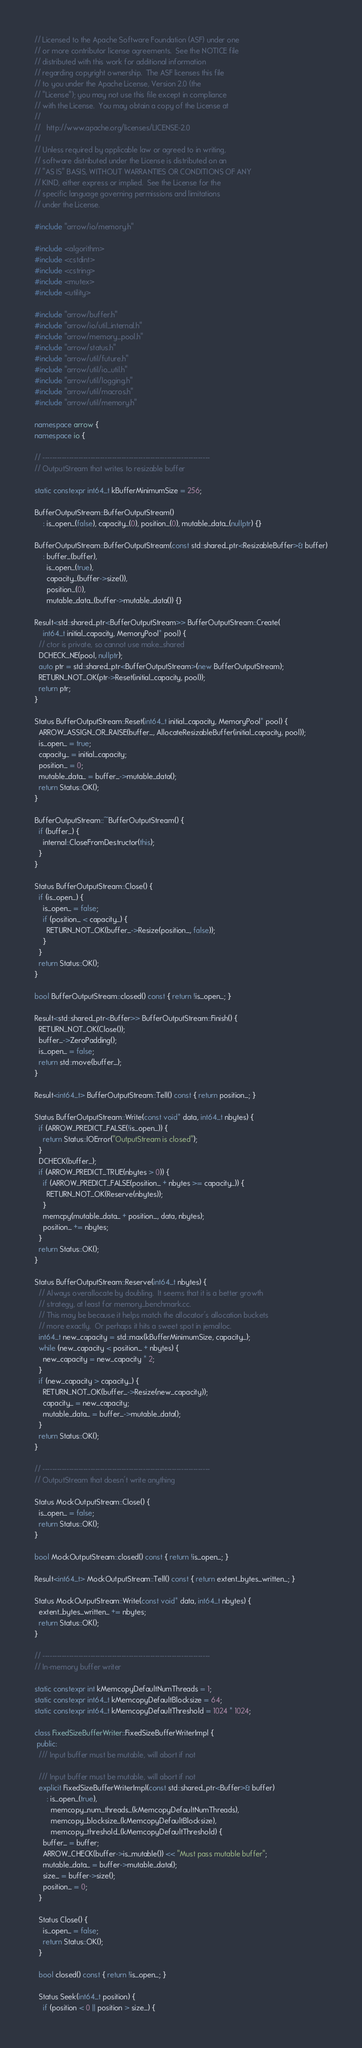Convert code to text. <code><loc_0><loc_0><loc_500><loc_500><_C++_>// Licensed to the Apache Software Foundation (ASF) under one
// or more contributor license agreements.  See the NOTICE file
// distributed with this work for additional information
// regarding copyright ownership.  The ASF licenses this file
// to you under the Apache License, Version 2.0 (the
// "License"); you may not use this file except in compliance
// with the License.  You may obtain a copy of the License at
//
//   http://www.apache.org/licenses/LICENSE-2.0
//
// Unless required by applicable law or agreed to in writing,
// software distributed under the License is distributed on an
// "AS IS" BASIS, WITHOUT WARRANTIES OR CONDITIONS OF ANY
// KIND, either express or implied.  See the License for the
// specific language governing permissions and limitations
// under the License.

#include "arrow/io/memory.h"

#include <algorithm>
#include <cstdint>
#include <cstring>
#include <mutex>
#include <utility>

#include "arrow/buffer.h"
#include "arrow/io/util_internal.h"
#include "arrow/memory_pool.h"
#include "arrow/status.h"
#include "arrow/util/future.h"
#include "arrow/util/io_util.h"
#include "arrow/util/logging.h"
#include "arrow/util/macros.h"
#include "arrow/util/memory.h"

namespace arrow {
namespace io {

// ----------------------------------------------------------------------
// OutputStream that writes to resizable buffer

static constexpr int64_t kBufferMinimumSize = 256;

BufferOutputStream::BufferOutputStream()
    : is_open_(false), capacity_(0), position_(0), mutable_data_(nullptr) {}

BufferOutputStream::BufferOutputStream(const std::shared_ptr<ResizableBuffer>& buffer)
    : buffer_(buffer),
      is_open_(true),
      capacity_(buffer->size()),
      position_(0),
      mutable_data_(buffer->mutable_data()) {}

Result<std::shared_ptr<BufferOutputStream>> BufferOutputStream::Create(
    int64_t initial_capacity, MemoryPool* pool) {
  // ctor is private, so cannot use make_shared
  DCHECK_NE(pool, nullptr);
  auto ptr = std::shared_ptr<BufferOutputStream>(new BufferOutputStream);
  RETURN_NOT_OK(ptr->Reset(initial_capacity, pool));
  return ptr;
}

Status BufferOutputStream::Reset(int64_t initial_capacity, MemoryPool* pool) {
  ARROW_ASSIGN_OR_RAISE(buffer_, AllocateResizableBuffer(initial_capacity, pool));
  is_open_ = true;
  capacity_ = initial_capacity;
  position_ = 0;
  mutable_data_ = buffer_->mutable_data();
  return Status::OK();
}

BufferOutputStream::~BufferOutputStream() {
  if (buffer_) {
    internal::CloseFromDestructor(this);
  }
}

Status BufferOutputStream::Close() {
  if (is_open_) {
    is_open_ = false;
    if (position_ < capacity_) {
      RETURN_NOT_OK(buffer_->Resize(position_, false));
    }
  }
  return Status::OK();
}

bool BufferOutputStream::closed() const { return !is_open_; }

Result<std::shared_ptr<Buffer>> BufferOutputStream::Finish() {
  RETURN_NOT_OK(Close());
  buffer_->ZeroPadding();
  is_open_ = false;
  return std::move(buffer_);
}

Result<int64_t> BufferOutputStream::Tell() const { return position_; }

Status BufferOutputStream::Write(const void* data, int64_t nbytes) {
  if (ARROW_PREDICT_FALSE(!is_open_)) {
    return Status::IOError("OutputStream is closed");
  }
  DCHECK(buffer_);
  if (ARROW_PREDICT_TRUE(nbytes > 0)) {
    if (ARROW_PREDICT_FALSE(position_ + nbytes >= capacity_)) {
      RETURN_NOT_OK(Reserve(nbytes));
    }
    memcpy(mutable_data_ + position_, data, nbytes);
    position_ += nbytes;
  }
  return Status::OK();
}

Status BufferOutputStream::Reserve(int64_t nbytes) {
  // Always overallocate by doubling.  It seems that it is a better growth
  // strategy, at least for memory_benchmark.cc.
  // This may be because it helps match the allocator's allocation buckets
  // more exactly.  Or perhaps it hits a sweet spot in jemalloc.
  int64_t new_capacity = std::max(kBufferMinimumSize, capacity_);
  while (new_capacity < position_ + nbytes) {
    new_capacity = new_capacity * 2;
  }
  if (new_capacity > capacity_) {
    RETURN_NOT_OK(buffer_->Resize(new_capacity));
    capacity_ = new_capacity;
    mutable_data_ = buffer_->mutable_data();
  }
  return Status::OK();
}

// ----------------------------------------------------------------------
// OutputStream that doesn't write anything

Status MockOutputStream::Close() {
  is_open_ = false;
  return Status::OK();
}

bool MockOutputStream::closed() const { return !is_open_; }

Result<int64_t> MockOutputStream::Tell() const { return extent_bytes_written_; }

Status MockOutputStream::Write(const void* data, int64_t nbytes) {
  extent_bytes_written_ += nbytes;
  return Status::OK();
}

// ----------------------------------------------------------------------
// In-memory buffer writer

static constexpr int kMemcopyDefaultNumThreads = 1;
static constexpr int64_t kMemcopyDefaultBlocksize = 64;
static constexpr int64_t kMemcopyDefaultThreshold = 1024 * 1024;

class FixedSizeBufferWriter::FixedSizeBufferWriterImpl {
 public:
  /// Input buffer must be mutable, will abort if not

  /// Input buffer must be mutable, will abort if not
  explicit FixedSizeBufferWriterImpl(const std::shared_ptr<Buffer>& buffer)
      : is_open_(true),
        memcopy_num_threads_(kMemcopyDefaultNumThreads),
        memcopy_blocksize_(kMemcopyDefaultBlocksize),
        memcopy_threshold_(kMemcopyDefaultThreshold) {
    buffer_ = buffer;
    ARROW_CHECK(buffer->is_mutable()) << "Must pass mutable buffer";
    mutable_data_ = buffer->mutable_data();
    size_ = buffer->size();
    position_ = 0;
  }

  Status Close() {
    is_open_ = false;
    return Status::OK();
  }

  bool closed() const { return !is_open_; }

  Status Seek(int64_t position) {
    if (position < 0 || position > size_) {</code> 